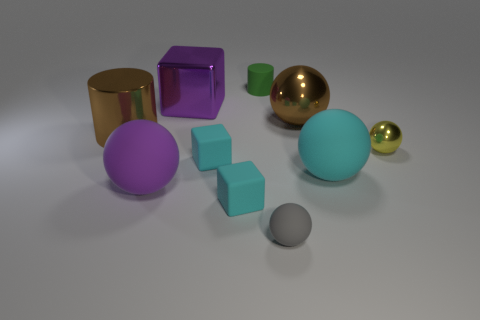There is a object that is the same color as the large cylinder; what is it made of?
Your response must be concise. Metal. Do the large sphere that is left of the small gray ball and the large block have the same color?
Your answer should be very brief. Yes. Are there any big metallic balls of the same color as the metal cylinder?
Your answer should be compact. Yes. There is a shiny sphere to the left of the yellow shiny sphere; does it have the same color as the large cylinder that is to the left of the big cyan rubber ball?
Your response must be concise. Yes. What shape is the big cyan object that is the same material as the gray sphere?
Your answer should be compact. Sphere. Are there any other things of the same color as the tiny rubber cylinder?
Your answer should be compact. No. The cylinder left of the cyan matte object that is behind the big cyan ball is what color?
Provide a succinct answer. Brown. How many big things are metal things or rubber cylinders?
Your answer should be compact. 3. What material is the large brown thing that is the same shape as the yellow metal thing?
Your answer should be very brief. Metal. Is there anything else that is made of the same material as the tiny gray object?
Give a very brief answer. Yes. 